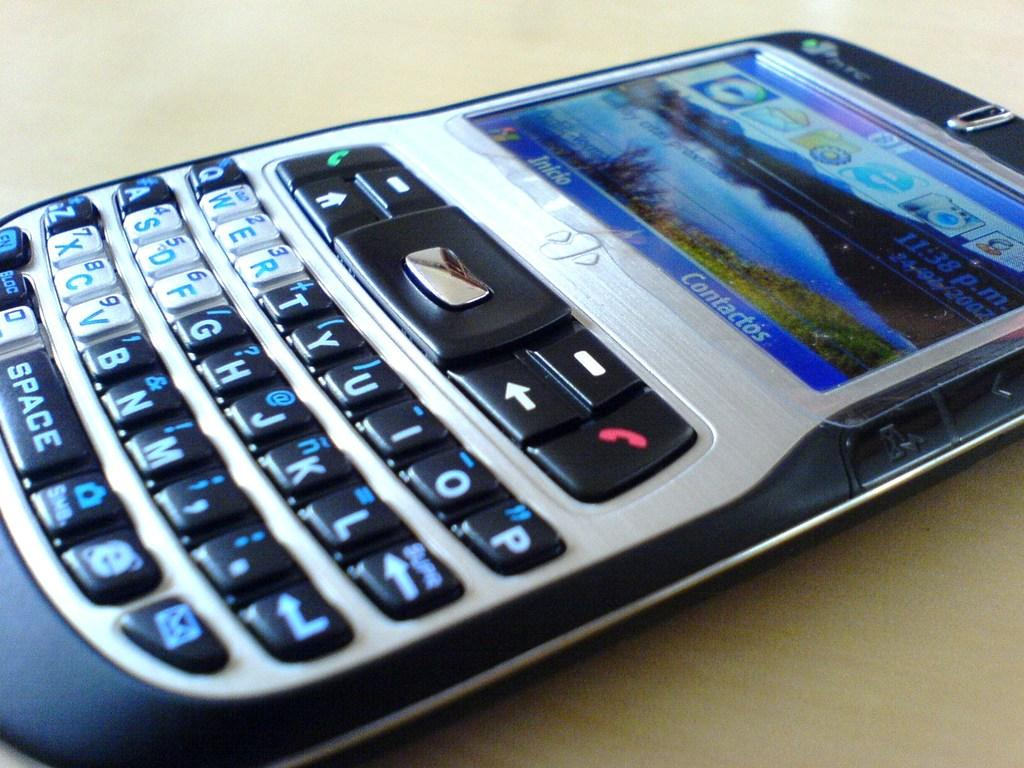Provide a one-sentence caption for the provided image. A HTC device sits on the table with its screen illuminated. 